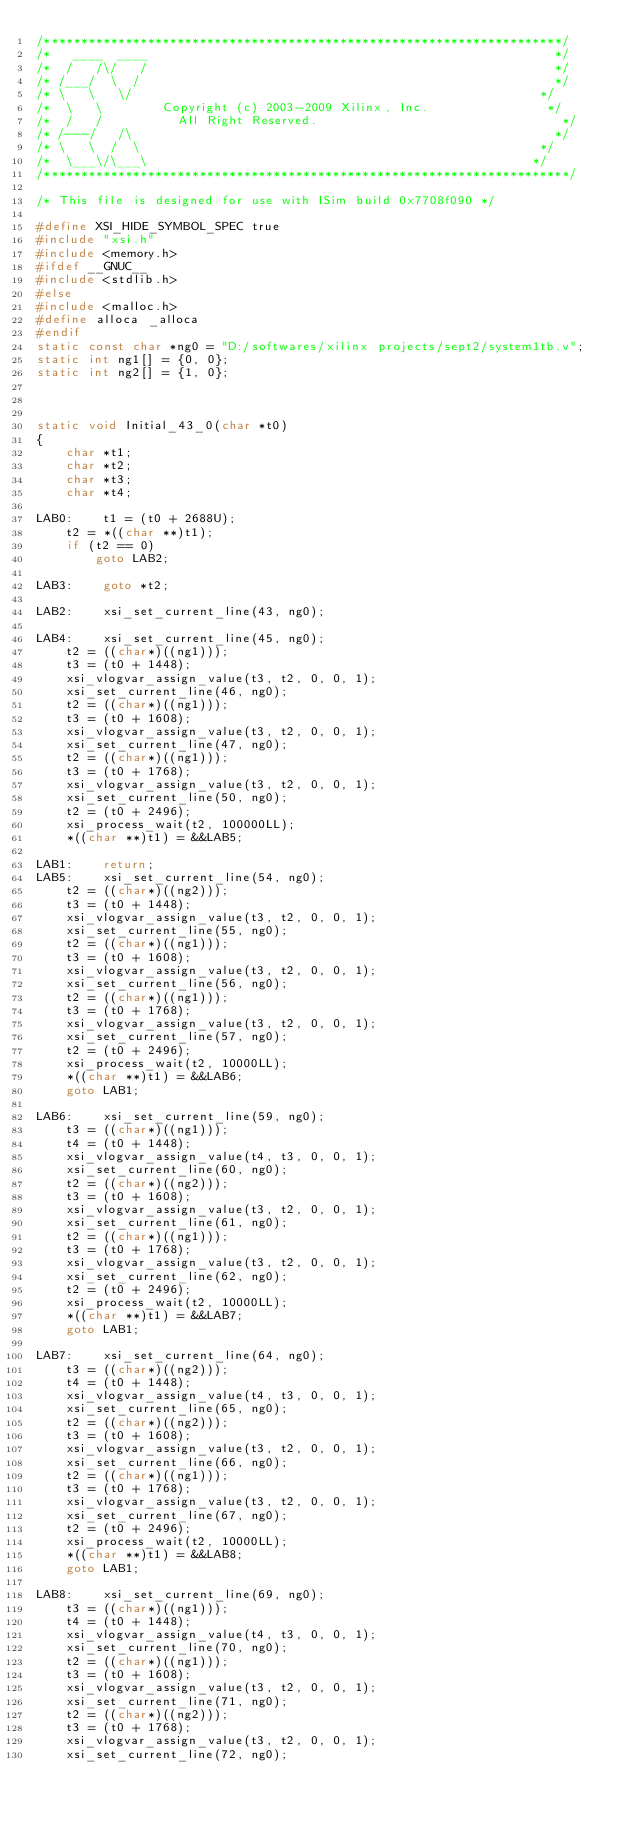Convert code to text. <code><loc_0><loc_0><loc_500><loc_500><_C_>/**********************************************************************/
/*   ____  ____                                                       */
/*  /   /\/   /                                                       */
/* /___/  \  /                                                        */
/* \   \   \/                                                       */
/*  \   \        Copyright (c) 2003-2009 Xilinx, Inc.                */
/*  /   /          All Right Reserved.                                 */
/* /---/   /\                                                         */
/* \   \  /  \                                                      */
/*  \___\/\___\                                                    */
/***********************************************************************/

/* This file is designed for use with ISim build 0x7708f090 */

#define XSI_HIDE_SYMBOL_SPEC true
#include "xsi.h"
#include <memory.h>
#ifdef __GNUC__
#include <stdlib.h>
#else
#include <malloc.h>
#define alloca _alloca
#endif
static const char *ng0 = "D:/softwares/xilinx projects/sept2/system1tb.v";
static int ng1[] = {0, 0};
static int ng2[] = {1, 0};



static void Initial_43_0(char *t0)
{
    char *t1;
    char *t2;
    char *t3;
    char *t4;

LAB0:    t1 = (t0 + 2688U);
    t2 = *((char **)t1);
    if (t2 == 0)
        goto LAB2;

LAB3:    goto *t2;

LAB2:    xsi_set_current_line(43, ng0);

LAB4:    xsi_set_current_line(45, ng0);
    t2 = ((char*)((ng1)));
    t3 = (t0 + 1448);
    xsi_vlogvar_assign_value(t3, t2, 0, 0, 1);
    xsi_set_current_line(46, ng0);
    t2 = ((char*)((ng1)));
    t3 = (t0 + 1608);
    xsi_vlogvar_assign_value(t3, t2, 0, 0, 1);
    xsi_set_current_line(47, ng0);
    t2 = ((char*)((ng1)));
    t3 = (t0 + 1768);
    xsi_vlogvar_assign_value(t3, t2, 0, 0, 1);
    xsi_set_current_line(50, ng0);
    t2 = (t0 + 2496);
    xsi_process_wait(t2, 100000LL);
    *((char **)t1) = &&LAB5;

LAB1:    return;
LAB5:    xsi_set_current_line(54, ng0);
    t2 = ((char*)((ng2)));
    t3 = (t0 + 1448);
    xsi_vlogvar_assign_value(t3, t2, 0, 0, 1);
    xsi_set_current_line(55, ng0);
    t2 = ((char*)((ng1)));
    t3 = (t0 + 1608);
    xsi_vlogvar_assign_value(t3, t2, 0, 0, 1);
    xsi_set_current_line(56, ng0);
    t2 = ((char*)((ng1)));
    t3 = (t0 + 1768);
    xsi_vlogvar_assign_value(t3, t2, 0, 0, 1);
    xsi_set_current_line(57, ng0);
    t2 = (t0 + 2496);
    xsi_process_wait(t2, 10000LL);
    *((char **)t1) = &&LAB6;
    goto LAB1;

LAB6:    xsi_set_current_line(59, ng0);
    t3 = ((char*)((ng1)));
    t4 = (t0 + 1448);
    xsi_vlogvar_assign_value(t4, t3, 0, 0, 1);
    xsi_set_current_line(60, ng0);
    t2 = ((char*)((ng2)));
    t3 = (t0 + 1608);
    xsi_vlogvar_assign_value(t3, t2, 0, 0, 1);
    xsi_set_current_line(61, ng0);
    t2 = ((char*)((ng1)));
    t3 = (t0 + 1768);
    xsi_vlogvar_assign_value(t3, t2, 0, 0, 1);
    xsi_set_current_line(62, ng0);
    t2 = (t0 + 2496);
    xsi_process_wait(t2, 10000LL);
    *((char **)t1) = &&LAB7;
    goto LAB1;

LAB7:    xsi_set_current_line(64, ng0);
    t3 = ((char*)((ng2)));
    t4 = (t0 + 1448);
    xsi_vlogvar_assign_value(t4, t3, 0, 0, 1);
    xsi_set_current_line(65, ng0);
    t2 = ((char*)((ng2)));
    t3 = (t0 + 1608);
    xsi_vlogvar_assign_value(t3, t2, 0, 0, 1);
    xsi_set_current_line(66, ng0);
    t2 = ((char*)((ng1)));
    t3 = (t0 + 1768);
    xsi_vlogvar_assign_value(t3, t2, 0, 0, 1);
    xsi_set_current_line(67, ng0);
    t2 = (t0 + 2496);
    xsi_process_wait(t2, 10000LL);
    *((char **)t1) = &&LAB8;
    goto LAB1;

LAB8:    xsi_set_current_line(69, ng0);
    t3 = ((char*)((ng1)));
    t4 = (t0 + 1448);
    xsi_vlogvar_assign_value(t4, t3, 0, 0, 1);
    xsi_set_current_line(70, ng0);
    t2 = ((char*)((ng1)));
    t3 = (t0 + 1608);
    xsi_vlogvar_assign_value(t3, t2, 0, 0, 1);
    xsi_set_current_line(71, ng0);
    t2 = ((char*)((ng2)));
    t3 = (t0 + 1768);
    xsi_vlogvar_assign_value(t3, t2, 0, 0, 1);
    xsi_set_current_line(72, ng0);</code> 